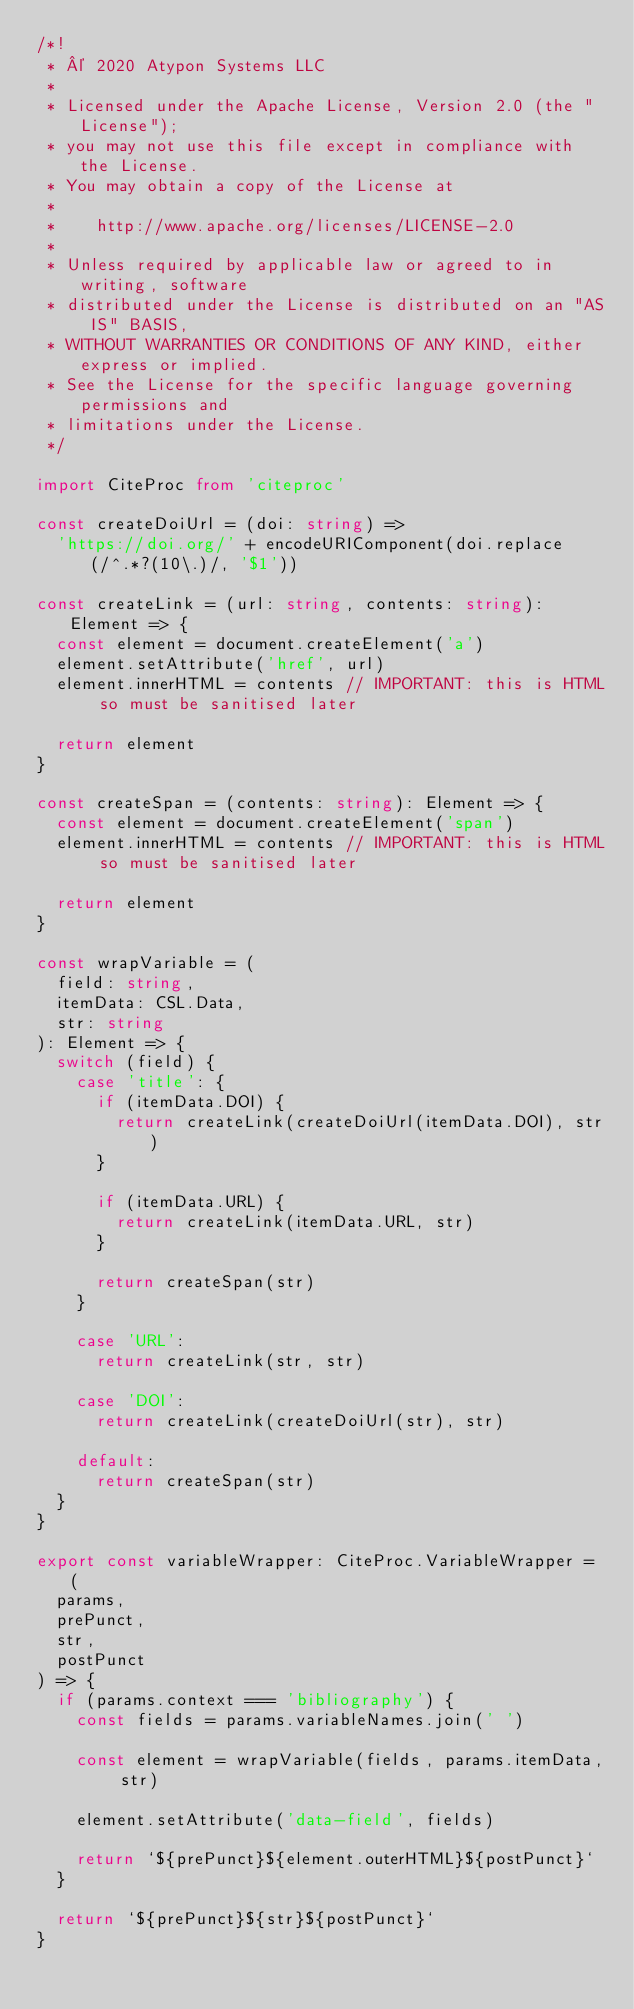Convert code to text. <code><loc_0><loc_0><loc_500><loc_500><_TypeScript_>/*!
 * © 2020 Atypon Systems LLC
 *
 * Licensed under the Apache License, Version 2.0 (the "License");
 * you may not use this file except in compliance with the License.
 * You may obtain a copy of the License at
 *
 *    http://www.apache.org/licenses/LICENSE-2.0
 *
 * Unless required by applicable law or agreed to in writing, software
 * distributed under the License is distributed on an "AS IS" BASIS,
 * WITHOUT WARRANTIES OR CONDITIONS OF ANY KIND, either express or implied.
 * See the License for the specific language governing permissions and
 * limitations under the License.
 */

import CiteProc from 'citeproc'

const createDoiUrl = (doi: string) =>
  'https://doi.org/' + encodeURIComponent(doi.replace(/^.*?(10\.)/, '$1'))

const createLink = (url: string, contents: string): Element => {
  const element = document.createElement('a')
  element.setAttribute('href', url)
  element.innerHTML = contents // IMPORTANT: this is HTML so must be sanitised later

  return element
}

const createSpan = (contents: string): Element => {
  const element = document.createElement('span')
  element.innerHTML = contents // IMPORTANT: this is HTML so must be sanitised later

  return element
}

const wrapVariable = (
  field: string,
  itemData: CSL.Data,
  str: string
): Element => {
  switch (field) {
    case 'title': {
      if (itemData.DOI) {
        return createLink(createDoiUrl(itemData.DOI), str)
      }

      if (itemData.URL) {
        return createLink(itemData.URL, str)
      }

      return createSpan(str)
    }

    case 'URL':
      return createLink(str, str)

    case 'DOI':
      return createLink(createDoiUrl(str), str)

    default:
      return createSpan(str)
  }
}

export const variableWrapper: CiteProc.VariableWrapper = (
  params,
  prePunct,
  str,
  postPunct
) => {
  if (params.context === 'bibliography') {
    const fields = params.variableNames.join(' ')

    const element = wrapVariable(fields, params.itemData, str)

    element.setAttribute('data-field', fields)

    return `${prePunct}${element.outerHTML}${postPunct}`
  }

  return `${prePunct}${str}${postPunct}`
}
</code> 